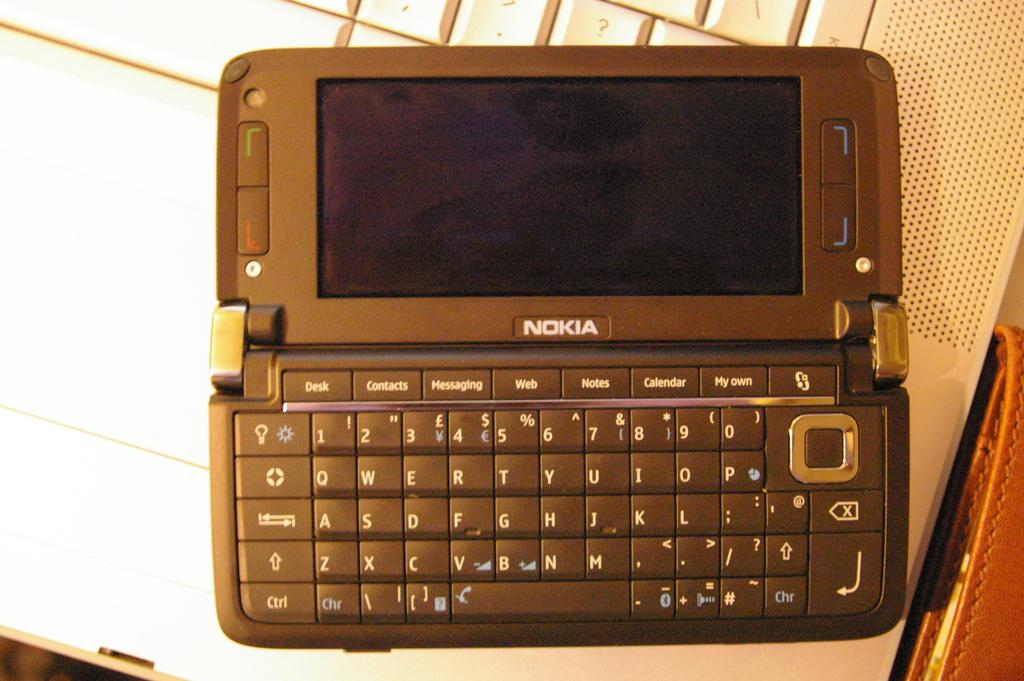<image>
Present a compact description of the photo's key features. A Nokia brand phone with a full qwerty keyboard. 